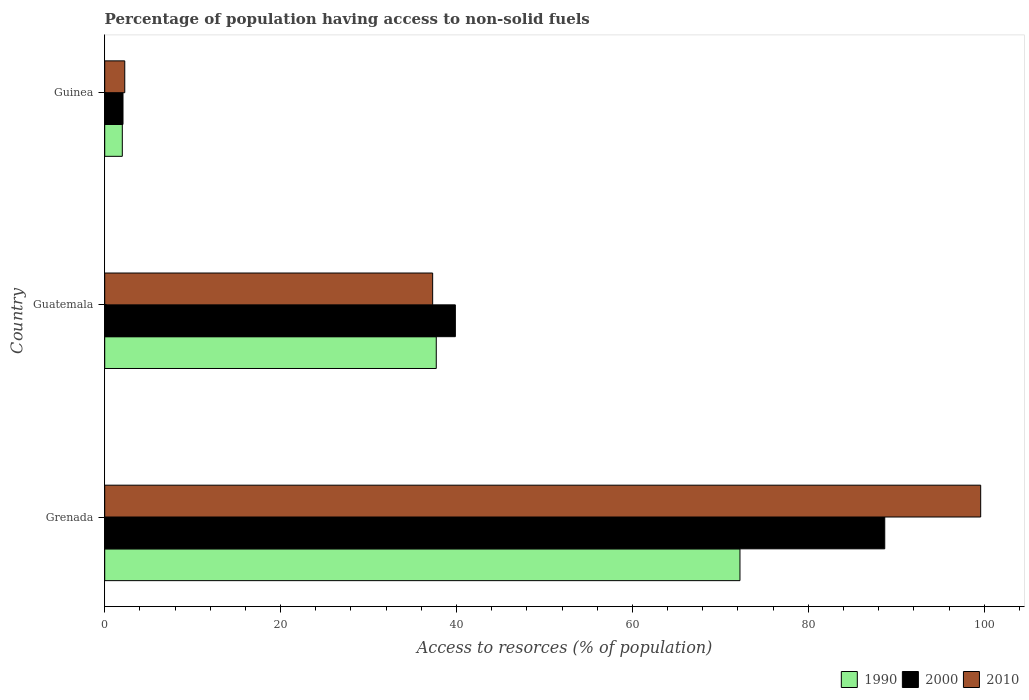Are the number of bars per tick equal to the number of legend labels?
Your answer should be very brief. Yes. Are the number of bars on each tick of the Y-axis equal?
Make the answer very short. Yes. How many bars are there on the 2nd tick from the top?
Offer a terse response. 3. How many bars are there on the 2nd tick from the bottom?
Your answer should be compact. 3. What is the label of the 3rd group of bars from the top?
Ensure brevity in your answer.  Grenada. What is the percentage of population having access to non-solid fuels in 2000 in Grenada?
Keep it short and to the point. 88.69. Across all countries, what is the maximum percentage of population having access to non-solid fuels in 2000?
Make the answer very short. 88.69. Across all countries, what is the minimum percentage of population having access to non-solid fuels in 2000?
Keep it short and to the point. 2.08. In which country was the percentage of population having access to non-solid fuels in 2000 maximum?
Offer a very short reply. Grenada. In which country was the percentage of population having access to non-solid fuels in 2000 minimum?
Provide a short and direct response. Guinea. What is the total percentage of population having access to non-solid fuels in 2000 in the graph?
Provide a succinct answer. 130.65. What is the difference between the percentage of population having access to non-solid fuels in 1990 in Grenada and that in Guinea?
Your answer should be compact. 70.23. What is the difference between the percentage of population having access to non-solid fuels in 2010 in Grenada and the percentage of population having access to non-solid fuels in 1990 in Guinea?
Ensure brevity in your answer.  97.6. What is the average percentage of population having access to non-solid fuels in 2010 per country?
Offer a terse response. 46.39. What is the difference between the percentage of population having access to non-solid fuels in 2000 and percentage of population having access to non-solid fuels in 1990 in Guinea?
Your response must be concise. 0.08. In how many countries, is the percentage of population having access to non-solid fuels in 2010 greater than 60 %?
Offer a very short reply. 1. What is the ratio of the percentage of population having access to non-solid fuels in 1990 in Guatemala to that in Guinea?
Offer a very short reply. 18.85. Is the percentage of population having access to non-solid fuels in 2010 in Guatemala less than that in Guinea?
Ensure brevity in your answer.  No. Is the difference between the percentage of population having access to non-solid fuels in 2000 in Grenada and Guatemala greater than the difference between the percentage of population having access to non-solid fuels in 1990 in Grenada and Guatemala?
Keep it short and to the point. Yes. What is the difference between the highest and the second highest percentage of population having access to non-solid fuels in 1990?
Offer a terse response. 34.53. What is the difference between the highest and the lowest percentage of population having access to non-solid fuels in 2010?
Provide a short and direct response. 97.33. In how many countries, is the percentage of population having access to non-solid fuels in 2010 greater than the average percentage of population having access to non-solid fuels in 2010 taken over all countries?
Provide a short and direct response. 1. Is the sum of the percentage of population having access to non-solid fuels in 2010 in Grenada and Guinea greater than the maximum percentage of population having access to non-solid fuels in 2000 across all countries?
Give a very brief answer. Yes. How many countries are there in the graph?
Offer a very short reply. 3. Does the graph contain any zero values?
Your answer should be compact. No. Does the graph contain grids?
Your answer should be compact. No. How many legend labels are there?
Your response must be concise. 3. What is the title of the graph?
Keep it short and to the point. Percentage of population having access to non-solid fuels. Does "1993" appear as one of the legend labels in the graph?
Offer a very short reply. No. What is the label or title of the X-axis?
Provide a succinct answer. Access to resorces (% of population). What is the label or title of the Y-axis?
Provide a succinct answer. Country. What is the Access to resorces (% of population) of 1990 in Grenada?
Provide a succinct answer. 72.23. What is the Access to resorces (% of population) in 2000 in Grenada?
Offer a terse response. 88.69. What is the Access to resorces (% of population) of 2010 in Grenada?
Give a very brief answer. 99.6. What is the Access to resorces (% of population) in 1990 in Guatemala?
Your answer should be compact. 37.7. What is the Access to resorces (% of population) in 2000 in Guatemala?
Your answer should be very brief. 39.87. What is the Access to resorces (% of population) of 2010 in Guatemala?
Offer a very short reply. 37.29. What is the Access to resorces (% of population) of 1990 in Guinea?
Ensure brevity in your answer.  2. What is the Access to resorces (% of population) in 2000 in Guinea?
Your answer should be very brief. 2.08. What is the Access to resorces (% of population) of 2010 in Guinea?
Provide a short and direct response. 2.28. Across all countries, what is the maximum Access to resorces (% of population) of 1990?
Your response must be concise. 72.23. Across all countries, what is the maximum Access to resorces (% of population) in 2000?
Ensure brevity in your answer.  88.69. Across all countries, what is the maximum Access to resorces (% of population) of 2010?
Make the answer very short. 99.6. Across all countries, what is the minimum Access to resorces (% of population) of 1990?
Give a very brief answer. 2. Across all countries, what is the minimum Access to resorces (% of population) of 2000?
Your answer should be compact. 2.08. Across all countries, what is the minimum Access to resorces (% of population) of 2010?
Ensure brevity in your answer.  2.28. What is the total Access to resorces (% of population) of 1990 in the graph?
Keep it short and to the point. 111.93. What is the total Access to resorces (% of population) of 2000 in the graph?
Your answer should be very brief. 130.65. What is the total Access to resorces (% of population) in 2010 in the graph?
Make the answer very short. 139.17. What is the difference between the Access to resorces (% of population) in 1990 in Grenada and that in Guatemala?
Offer a very short reply. 34.53. What is the difference between the Access to resorces (% of population) of 2000 in Grenada and that in Guatemala?
Your response must be concise. 48.82. What is the difference between the Access to resorces (% of population) in 2010 in Grenada and that in Guatemala?
Ensure brevity in your answer.  62.32. What is the difference between the Access to resorces (% of population) of 1990 in Grenada and that in Guinea?
Make the answer very short. 70.23. What is the difference between the Access to resorces (% of population) of 2000 in Grenada and that in Guinea?
Offer a terse response. 86.61. What is the difference between the Access to resorces (% of population) of 2010 in Grenada and that in Guinea?
Your response must be concise. 97.33. What is the difference between the Access to resorces (% of population) of 1990 in Guatemala and that in Guinea?
Offer a terse response. 35.7. What is the difference between the Access to resorces (% of population) in 2000 in Guatemala and that in Guinea?
Your response must be concise. 37.79. What is the difference between the Access to resorces (% of population) in 2010 in Guatemala and that in Guinea?
Offer a terse response. 35.01. What is the difference between the Access to resorces (% of population) in 1990 in Grenada and the Access to resorces (% of population) in 2000 in Guatemala?
Offer a terse response. 32.36. What is the difference between the Access to resorces (% of population) in 1990 in Grenada and the Access to resorces (% of population) in 2010 in Guatemala?
Provide a short and direct response. 34.94. What is the difference between the Access to resorces (% of population) of 2000 in Grenada and the Access to resorces (% of population) of 2010 in Guatemala?
Keep it short and to the point. 51.41. What is the difference between the Access to resorces (% of population) of 1990 in Grenada and the Access to resorces (% of population) of 2000 in Guinea?
Your answer should be very brief. 70.15. What is the difference between the Access to resorces (% of population) of 1990 in Grenada and the Access to resorces (% of population) of 2010 in Guinea?
Offer a very short reply. 69.95. What is the difference between the Access to resorces (% of population) of 2000 in Grenada and the Access to resorces (% of population) of 2010 in Guinea?
Offer a terse response. 86.42. What is the difference between the Access to resorces (% of population) of 1990 in Guatemala and the Access to resorces (% of population) of 2000 in Guinea?
Offer a very short reply. 35.62. What is the difference between the Access to resorces (% of population) in 1990 in Guatemala and the Access to resorces (% of population) in 2010 in Guinea?
Offer a very short reply. 35.42. What is the difference between the Access to resorces (% of population) of 2000 in Guatemala and the Access to resorces (% of population) of 2010 in Guinea?
Ensure brevity in your answer.  37.59. What is the average Access to resorces (% of population) in 1990 per country?
Provide a short and direct response. 37.31. What is the average Access to resorces (% of population) in 2000 per country?
Your response must be concise. 43.55. What is the average Access to resorces (% of population) in 2010 per country?
Offer a terse response. 46.39. What is the difference between the Access to resorces (% of population) of 1990 and Access to resorces (% of population) of 2000 in Grenada?
Ensure brevity in your answer.  -16.46. What is the difference between the Access to resorces (% of population) of 1990 and Access to resorces (% of population) of 2010 in Grenada?
Ensure brevity in your answer.  -27.37. What is the difference between the Access to resorces (% of population) in 2000 and Access to resorces (% of population) in 2010 in Grenada?
Your response must be concise. -10.91. What is the difference between the Access to resorces (% of population) in 1990 and Access to resorces (% of population) in 2000 in Guatemala?
Ensure brevity in your answer.  -2.17. What is the difference between the Access to resorces (% of population) in 1990 and Access to resorces (% of population) in 2010 in Guatemala?
Ensure brevity in your answer.  0.41. What is the difference between the Access to resorces (% of population) in 2000 and Access to resorces (% of population) in 2010 in Guatemala?
Your response must be concise. 2.58. What is the difference between the Access to resorces (% of population) in 1990 and Access to resorces (% of population) in 2000 in Guinea?
Keep it short and to the point. -0.08. What is the difference between the Access to resorces (% of population) in 1990 and Access to resorces (% of population) in 2010 in Guinea?
Provide a short and direct response. -0.28. What is the ratio of the Access to resorces (% of population) of 1990 in Grenada to that in Guatemala?
Your answer should be compact. 1.92. What is the ratio of the Access to resorces (% of population) in 2000 in Grenada to that in Guatemala?
Your answer should be compact. 2.22. What is the ratio of the Access to resorces (% of population) of 2010 in Grenada to that in Guatemala?
Give a very brief answer. 2.67. What is the ratio of the Access to resorces (% of population) in 1990 in Grenada to that in Guinea?
Give a very brief answer. 36.12. What is the ratio of the Access to resorces (% of population) in 2000 in Grenada to that in Guinea?
Your answer should be compact. 42.65. What is the ratio of the Access to resorces (% of population) in 2010 in Grenada to that in Guinea?
Keep it short and to the point. 43.7. What is the ratio of the Access to resorces (% of population) in 1990 in Guatemala to that in Guinea?
Your response must be concise. 18.85. What is the ratio of the Access to resorces (% of population) in 2000 in Guatemala to that in Guinea?
Your answer should be very brief. 19.17. What is the ratio of the Access to resorces (% of population) in 2010 in Guatemala to that in Guinea?
Make the answer very short. 16.36. What is the difference between the highest and the second highest Access to resorces (% of population) of 1990?
Your answer should be very brief. 34.53. What is the difference between the highest and the second highest Access to resorces (% of population) in 2000?
Provide a succinct answer. 48.82. What is the difference between the highest and the second highest Access to resorces (% of population) in 2010?
Provide a succinct answer. 62.32. What is the difference between the highest and the lowest Access to resorces (% of population) in 1990?
Keep it short and to the point. 70.23. What is the difference between the highest and the lowest Access to resorces (% of population) of 2000?
Make the answer very short. 86.61. What is the difference between the highest and the lowest Access to resorces (% of population) of 2010?
Offer a terse response. 97.33. 